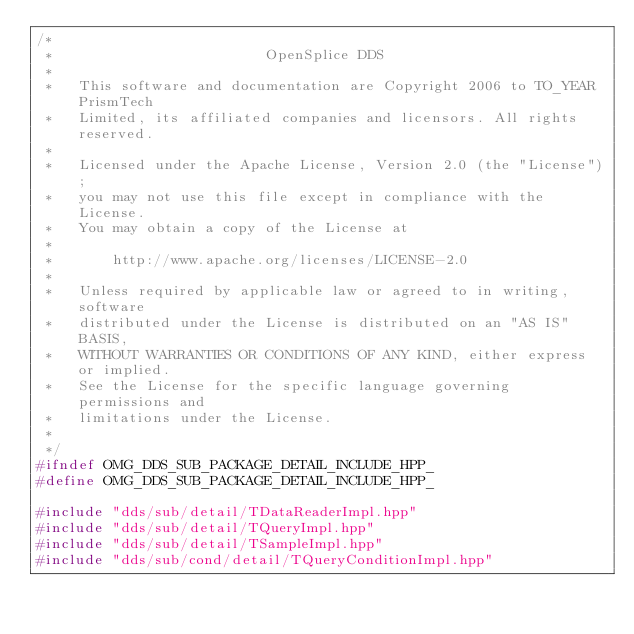Convert code to text. <code><loc_0><loc_0><loc_500><loc_500><_C++_>/*
 *                         OpenSplice DDS
 *
 *   This software and documentation are Copyright 2006 to TO_YEAR PrismTech
 *   Limited, its affiliated companies and licensors. All rights reserved.
 *
 *   Licensed under the Apache License, Version 2.0 (the "License");
 *   you may not use this file except in compliance with the License.
 *   You may obtain a copy of the License at
 *
 *       http://www.apache.org/licenses/LICENSE-2.0
 *
 *   Unless required by applicable law or agreed to in writing, software
 *   distributed under the License is distributed on an "AS IS" BASIS,
 *   WITHOUT WARRANTIES OR CONDITIONS OF ANY KIND, either express or implied.
 *   See the License for the specific language governing permissions and
 *   limitations under the License.
 *
 */
#ifndef OMG_DDS_SUB_PACKAGE_DETAIL_INCLUDE_HPP_
#define OMG_DDS_SUB_PACKAGE_DETAIL_INCLUDE_HPP_

#include "dds/sub/detail/TDataReaderImpl.hpp"
#include "dds/sub/detail/TQueryImpl.hpp"
#include "dds/sub/detail/TSampleImpl.hpp"
#include "dds/sub/cond/detail/TQueryConditionImpl.hpp"
</code> 